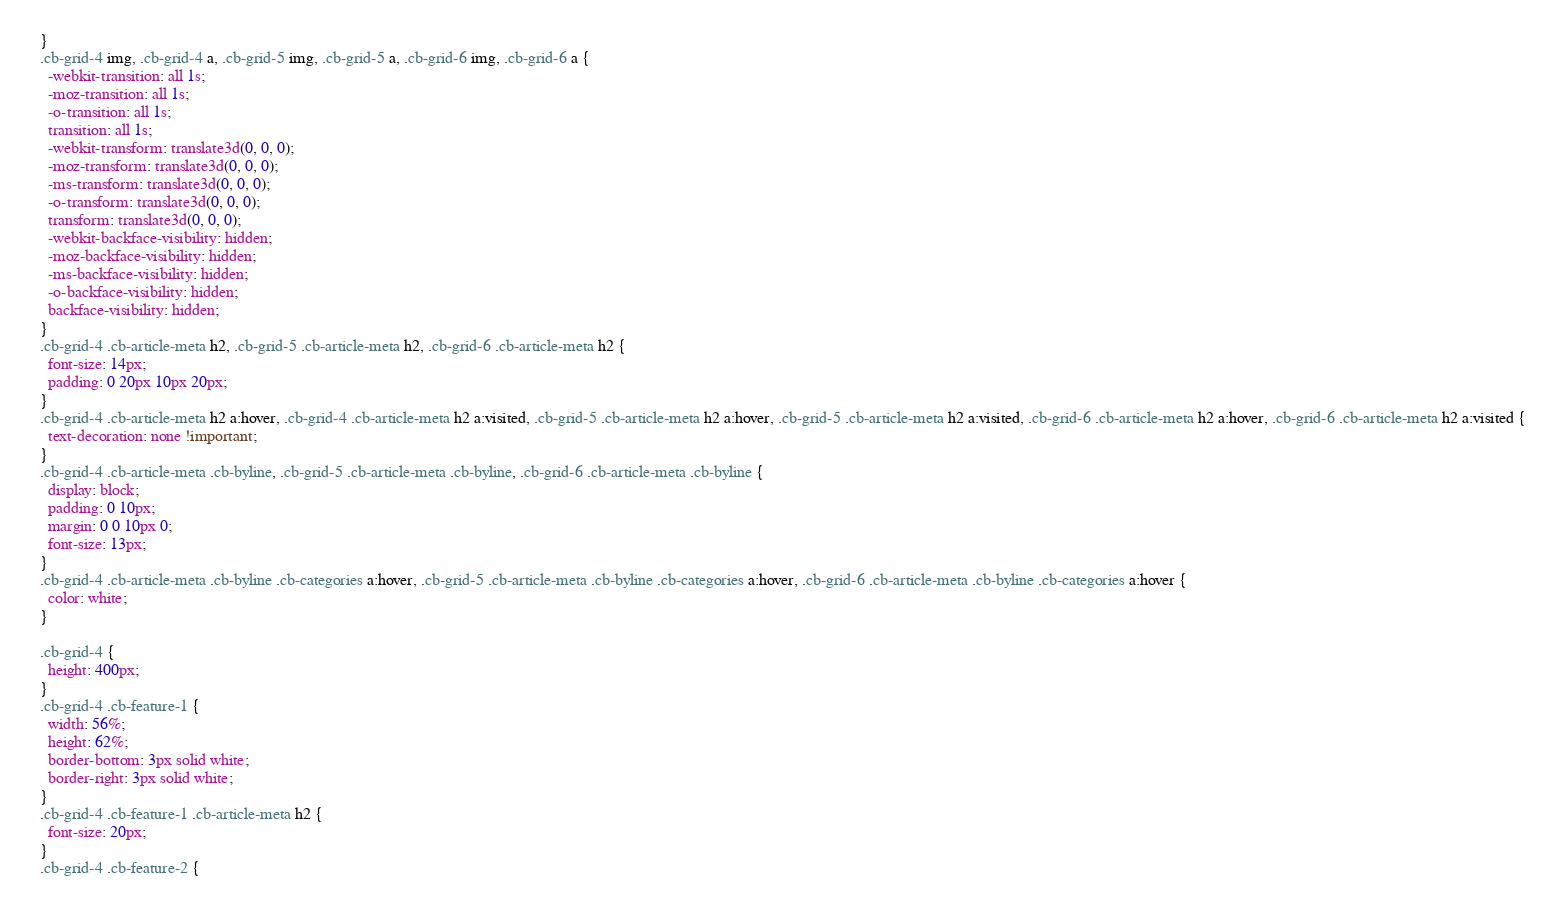<code> <loc_0><loc_0><loc_500><loc_500><_CSS_>  }
  .cb-grid-4 img, .cb-grid-4 a, .cb-grid-5 img, .cb-grid-5 a, .cb-grid-6 img, .cb-grid-6 a {
    -webkit-transition: all 1s;
    -moz-transition: all 1s;
    -o-transition: all 1s;
    transition: all 1s;
    -webkit-transform: translate3d(0, 0, 0);
    -moz-transform: translate3d(0, 0, 0);
    -ms-transform: translate3d(0, 0, 0);
    -o-transform: translate3d(0, 0, 0);
    transform: translate3d(0, 0, 0);
    -webkit-backface-visibility: hidden;
    -moz-backface-visibility: hidden;
    -ms-backface-visibility: hidden;
    -o-backface-visibility: hidden;
    backface-visibility: hidden;
  }
  .cb-grid-4 .cb-article-meta h2, .cb-grid-5 .cb-article-meta h2, .cb-grid-6 .cb-article-meta h2 {
    font-size: 14px;
    padding: 0 20px 10px 20px;
  }
  .cb-grid-4 .cb-article-meta h2 a:hover, .cb-grid-4 .cb-article-meta h2 a:visited, .cb-grid-5 .cb-article-meta h2 a:hover, .cb-grid-5 .cb-article-meta h2 a:visited, .cb-grid-6 .cb-article-meta h2 a:hover, .cb-grid-6 .cb-article-meta h2 a:visited {
    text-decoration: none !important;
  }
  .cb-grid-4 .cb-article-meta .cb-byline, .cb-grid-5 .cb-article-meta .cb-byline, .cb-grid-6 .cb-article-meta .cb-byline {
    display: block;
    padding: 0 10px;
    margin: 0 0 10px 0;
    font-size: 13px;
  }
  .cb-grid-4 .cb-article-meta .cb-byline .cb-categories a:hover, .cb-grid-5 .cb-article-meta .cb-byline .cb-categories a:hover, .cb-grid-6 .cb-article-meta .cb-byline .cb-categories a:hover {
    color: white;
  }

  .cb-grid-4 {
    height: 400px;
  }
  .cb-grid-4 .cb-feature-1 {
    width: 56%;
    height: 62%;
    border-bottom: 3px solid white;
    border-right: 3px solid white;
  }
  .cb-grid-4 .cb-feature-1 .cb-article-meta h2 {
    font-size: 20px;
  }
  .cb-grid-4 .cb-feature-2 {</code> 